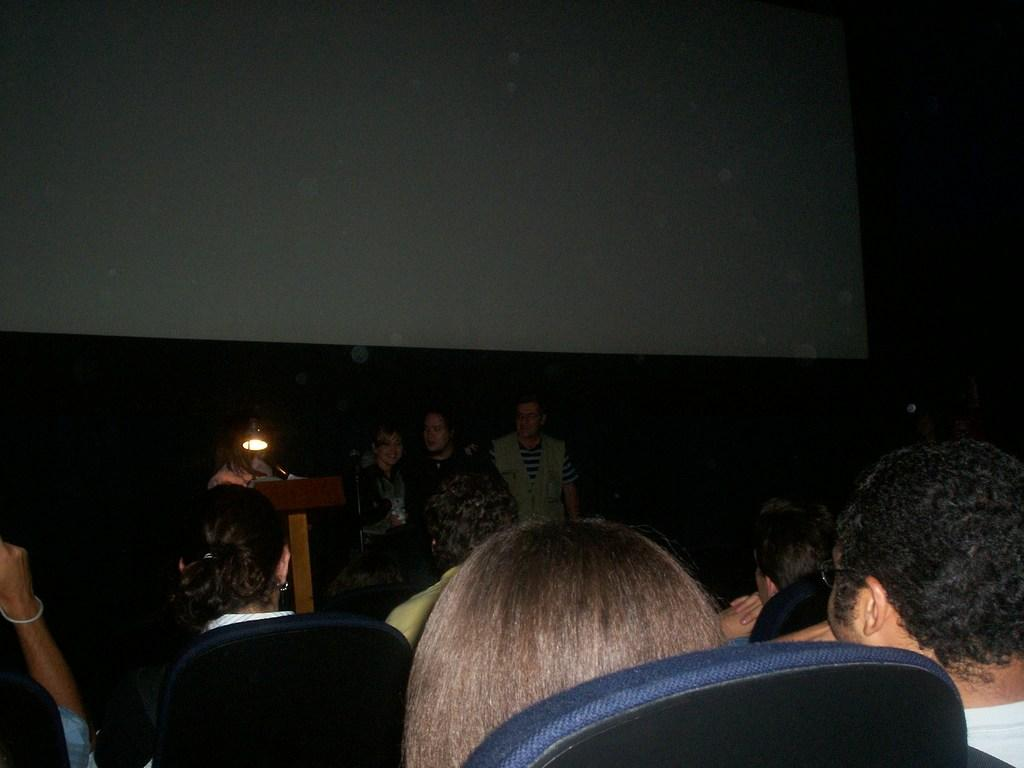What are the persons in the bottom of the image doing? The persons in the bottom of the image are sitting. What are the persons in the middle of the image doing? The persons in the middle of the image are standing. What can be seen in the background of the image? There is a wall in the background of the image. What type of pies are being supported by the wall in the image? There are no pies present in the image, and the wall is not supporting any pies. 